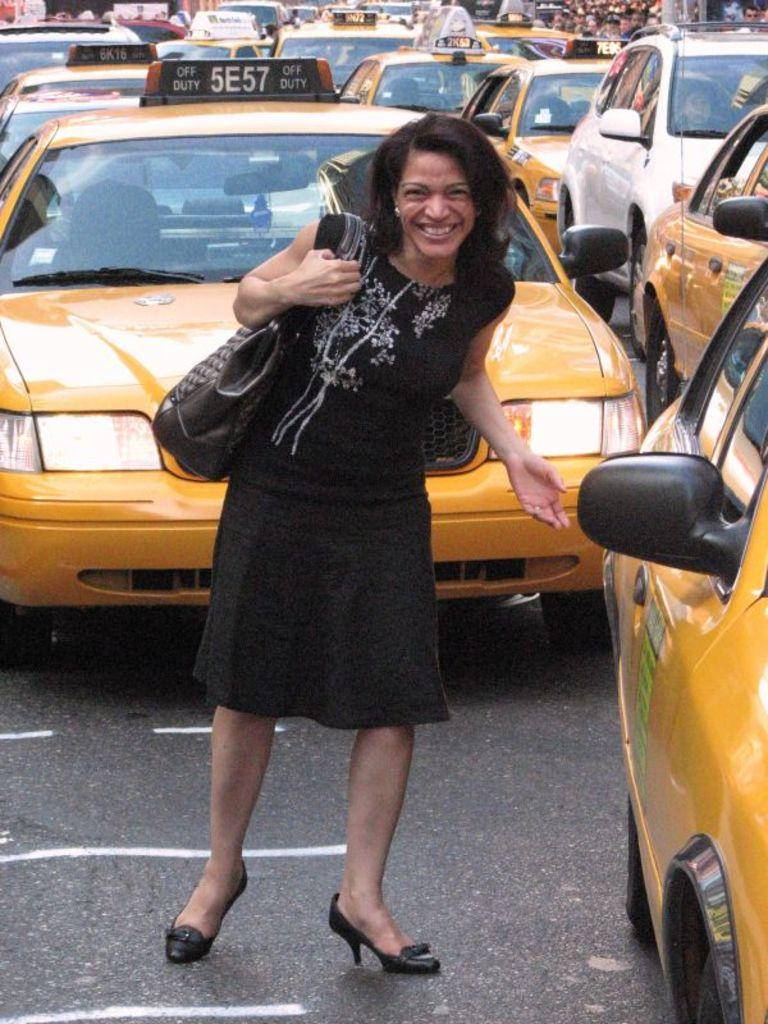Provide a one-sentence caption for the provided image. A woman standing infront of a taxi number 5E57. 